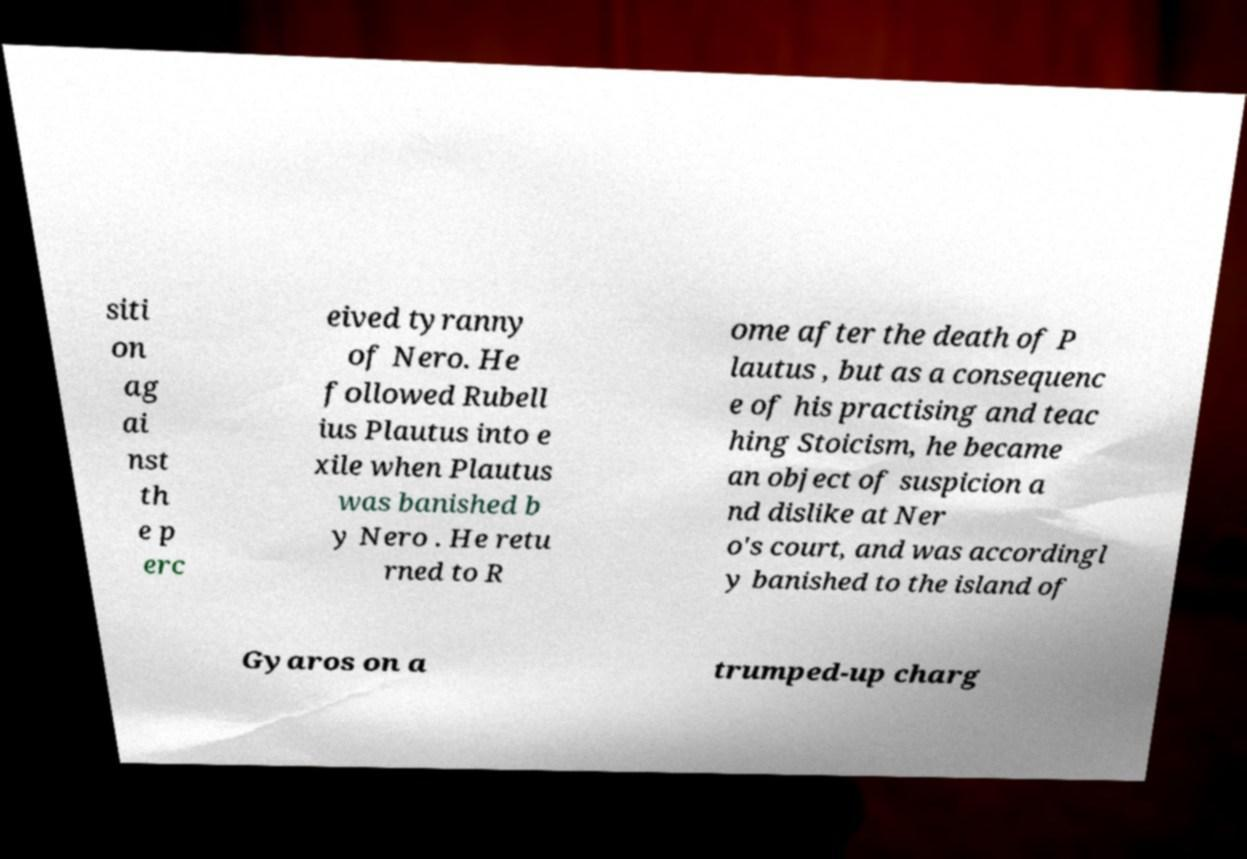There's text embedded in this image that I need extracted. Can you transcribe it verbatim? siti on ag ai nst th e p erc eived tyranny of Nero. He followed Rubell ius Plautus into e xile when Plautus was banished b y Nero . He retu rned to R ome after the death of P lautus , but as a consequenc e of his practising and teac hing Stoicism, he became an object of suspicion a nd dislike at Ner o's court, and was accordingl y banished to the island of Gyaros on a trumped-up charg 